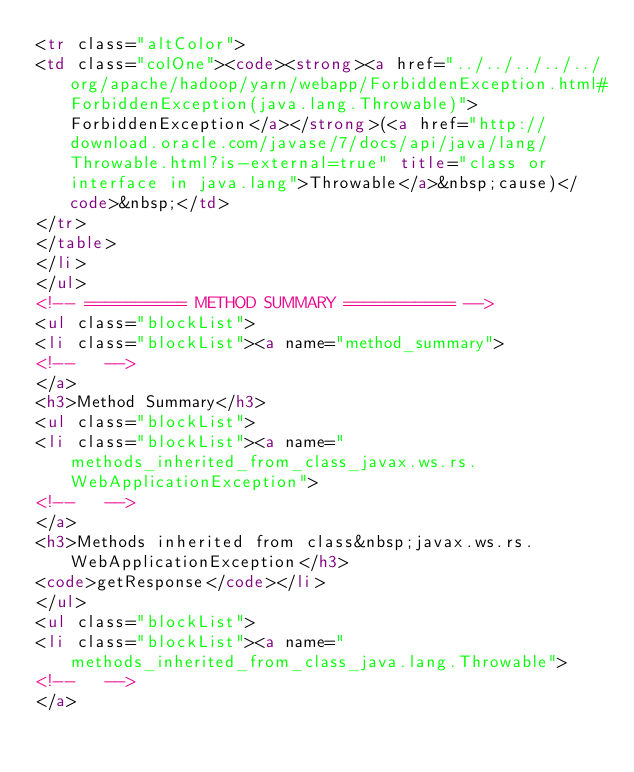Convert code to text. <code><loc_0><loc_0><loc_500><loc_500><_HTML_><tr class="altColor">
<td class="colOne"><code><strong><a href="../../../../../org/apache/hadoop/yarn/webapp/ForbiddenException.html#ForbiddenException(java.lang.Throwable)">ForbiddenException</a></strong>(<a href="http://download.oracle.com/javase/7/docs/api/java/lang/Throwable.html?is-external=true" title="class or interface in java.lang">Throwable</a>&nbsp;cause)</code>&nbsp;</td>
</tr>
</table>
</li>
</ul>
<!-- ========== METHOD SUMMARY =========== -->
<ul class="blockList">
<li class="blockList"><a name="method_summary">
<!--   -->
</a>
<h3>Method Summary</h3>
<ul class="blockList">
<li class="blockList"><a name="methods_inherited_from_class_javax.ws.rs.WebApplicationException">
<!--   -->
</a>
<h3>Methods inherited from class&nbsp;javax.ws.rs.WebApplicationException</h3>
<code>getResponse</code></li>
</ul>
<ul class="blockList">
<li class="blockList"><a name="methods_inherited_from_class_java.lang.Throwable">
<!--   -->
</a></code> 